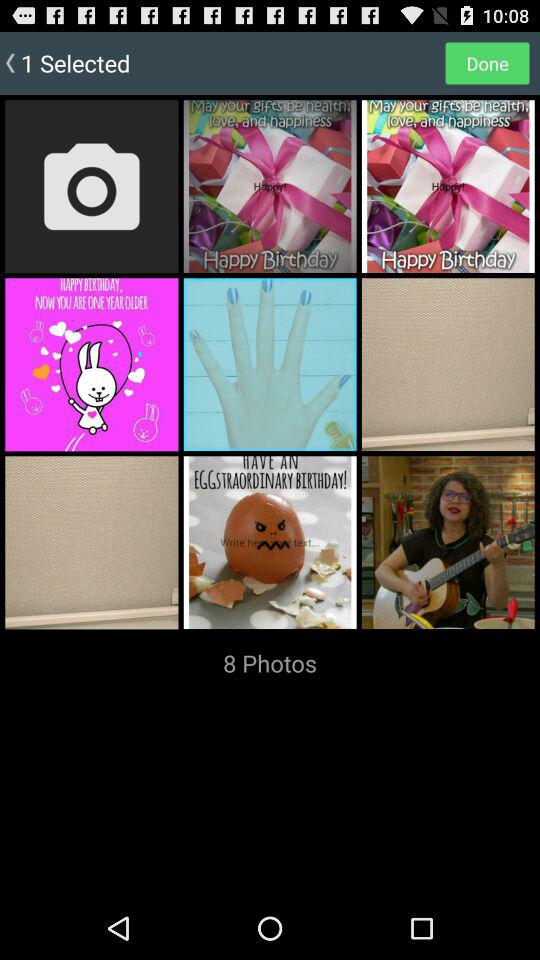What is the count of photos? The count of photos is 8. 